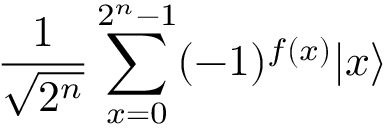<formula> <loc_0><loc_0><loc_500><loc_500>{ \frac { 1 } { \sqrt { 2 ^ { n } } } } \sum _ { x = 0 } ^ { 2 ^ { n } - 1 } ( - 1 ) ^ { f ( x ) } | x \rangle</formula> 